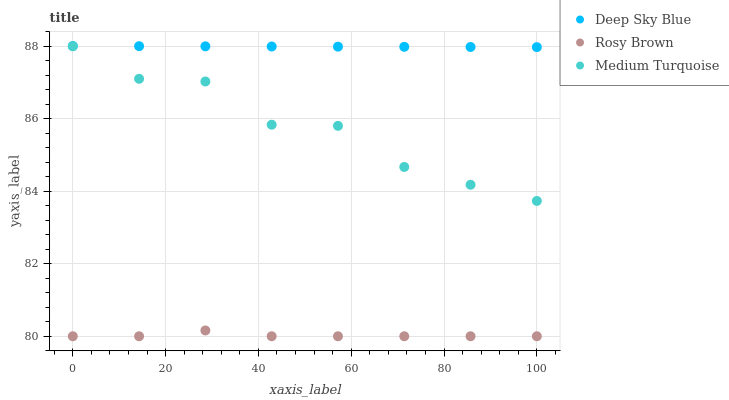Does Rosy Brown have the minimum area under the curve?
Answer yes or no. Yes. Does Deep Sky Blue have the maximum area under the curve?
Answer yes or no. Yes. Does Medium Turquoise have the minimum area under the curve?
Answer yes or no. No. Does Medium Turquoise have the maximum area under the curve?
Answer yes or no. No. Is Deep Sky Blue the smoothest?
Answer yes or no. Yes. Is Medium Turquoise the roughest?
Answer yes or no. Yes. Is Medium Turquoise the smoothest?
Answer yes or no. No. Is Deep Sky Blue the roughest?
Answer yes or no. No. Does Rosy Brown have the lowest value?
Answer yes or no. Yes. Does Medium Turquoise have the lowest value?
Answer yes or no. No. Does Deep Sky Blue have the highest value?
Answer yes or no. Yes. Does Medium Turquoise have the highest value?
Answer yes or no. No. Is Rosy Brown less than Medium Turquoise?
Answer yes or no. Yes. Is Deep Sky Blue greater than Medium Turquoise?
Answer yes or no. Yes. Does Rosy Brown intersect Medium Turquoise?
Answer yes or no. No. 